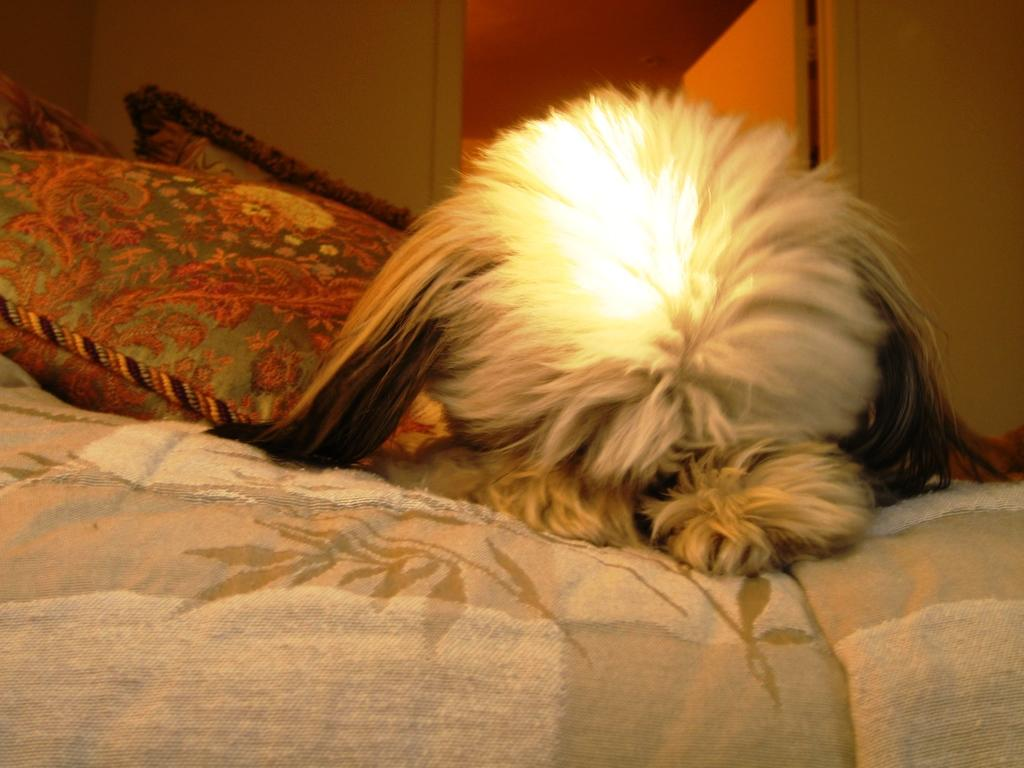What is lying on the bed in the image? There is an animal lying on the bed. What is located near the animal on the bed? There are pillows beside the animal. What can be seen in the background of the image? There is a wall and a door in the background of the image. How does the animal show respect to the pillows in the image? The image does not show the animal interacting with the pillows in a way that demonstrates respect. 